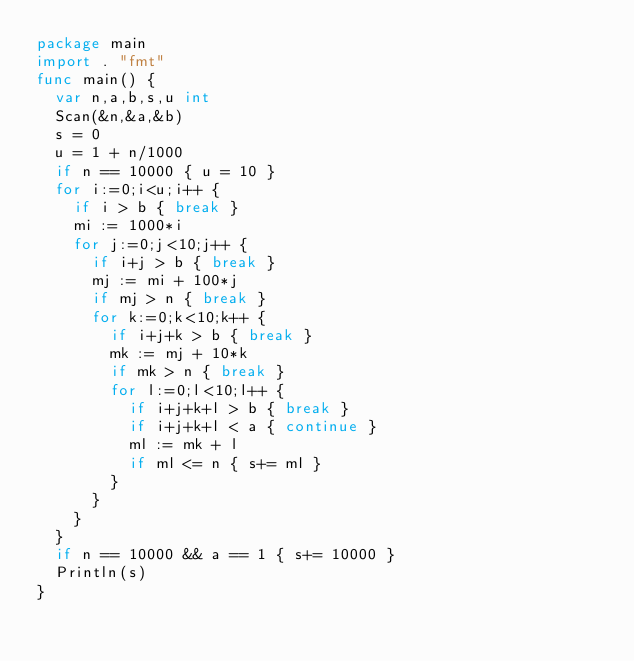<code> <loc_0><loc_0><loc_500><loc_500><_Go_>package main
import . "fmt"
func main() {
  var n,a,b,s,u int
  Scan(&n,&a,&b)
  s = 0
  u = 1 + n/1000
  if n == 10000 { u = 10 }
  for i:=0;i<u;i++ {
    if i > b { break }
    mi := 1000*i
    for j:=0;j<10;j++ {
      if i+j > b { break }
      mj := mi + 100*j
      if mj > n { break }
      for k:=0;k<10;k++ {
        if i+j+k > b { break }
        mk := mj + 10*k
        if mk > n { break }
        for l:=0;l<10;l++ {
          if i+j+k+l > b { break }
          if i+j+k+l < a { continue }
          ml := mk + l
          if ml <= n { s+= ml }
        }
      }
    }
  }
  if n == 10000 && a == 1 { s+= 10000 }
  Println(s)
}</code> 